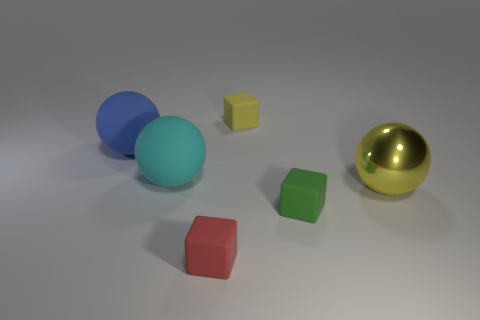Subtract all red balls. Subtract all green cubes. How many balls are left? 3 Add 3 small green rubber cubes. How many objects exist? 9 Subtract 0 brown cylinders. How many objects are left? 6 Subtract all yellow shiny balls. Subtract all big yellow metallic spheres. How many objects are left? 4 Add 6 blue objects. How many blue objects are left? 7 Add 5 large yellow metal balls. How many large yellow metal balls exist? 6 